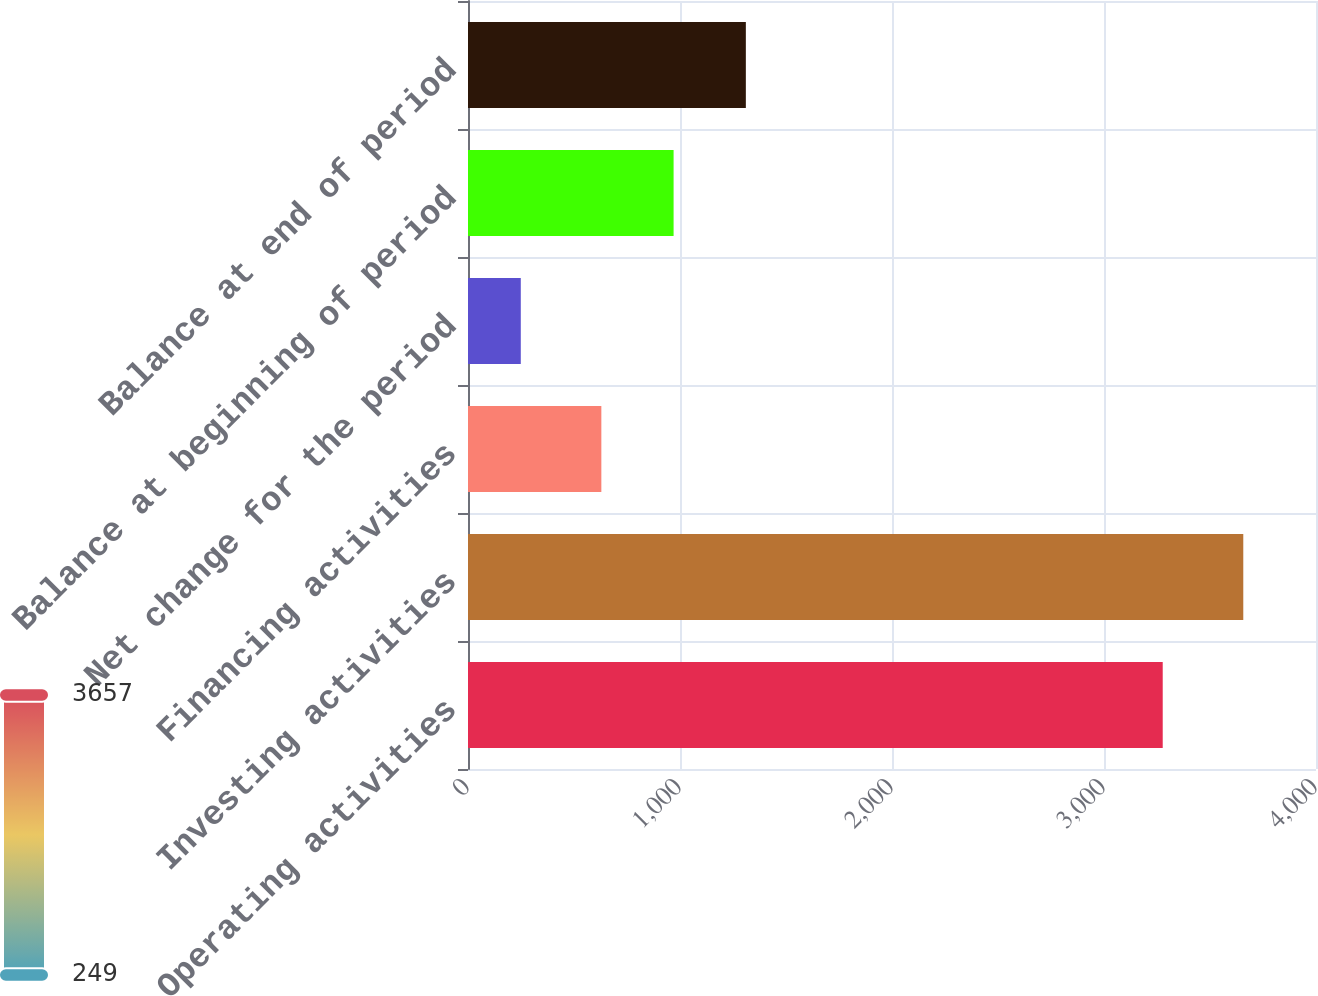Convert chart to OTSL. <chart><loc_0><loc_0><loc_500><loc_500><bar_chart><fcel>Operating activities<fcel>Investing activities<fcel>Financing activities<fcel>Net change for the period<fcel>Balance at beginning of period<fcel>Balance at end of period<nl><fcel>3277<fcel>3657<fcel>629<fcel>249<fcel>969.8<fcel>1310.6<nl></chart> 